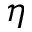Convert formula to latex. <formula><loc_0><loc_0><loc_500><loc_500>\boldsymbol \eta</formula> 